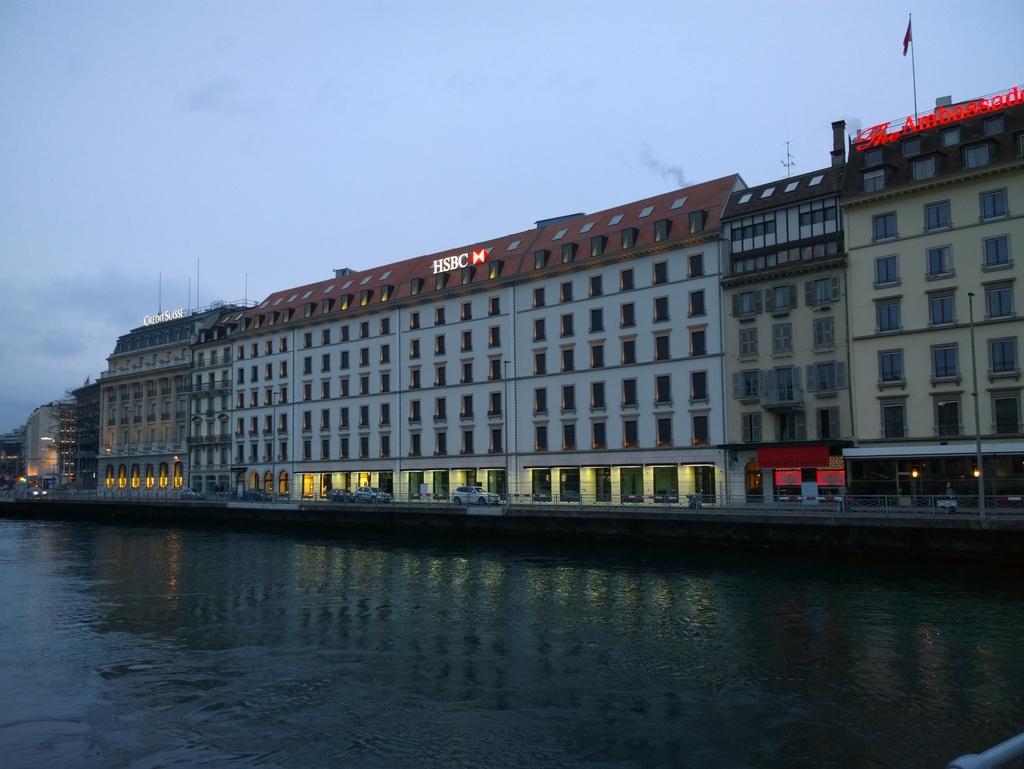Please provide a concise description of this image. In this image we can see building, name boards, flag, flag post, sky with clouds and water. 